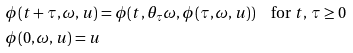<formula> <loc_0><loc_0><loc_500><loc_500>& \phi ( t + \tau , \omega , u ) = \phi ( t , \theta _ { \tau } \omega , \phi ( \tau , \omega , u ) ) \quad \text {for } t , \, \tau \geq 0 \\ & \phi ( 0 , \omega , u ) = u</formula> 